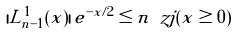Convert formula to latex. <formula><loc_0><loc_0><loc_500><loc_500>| L ^ { 1 } _ { n - 1 } ( x ) | \, e ^ { - x / 2 } \leq n \ z j ( x \geq 0 )</formula> 